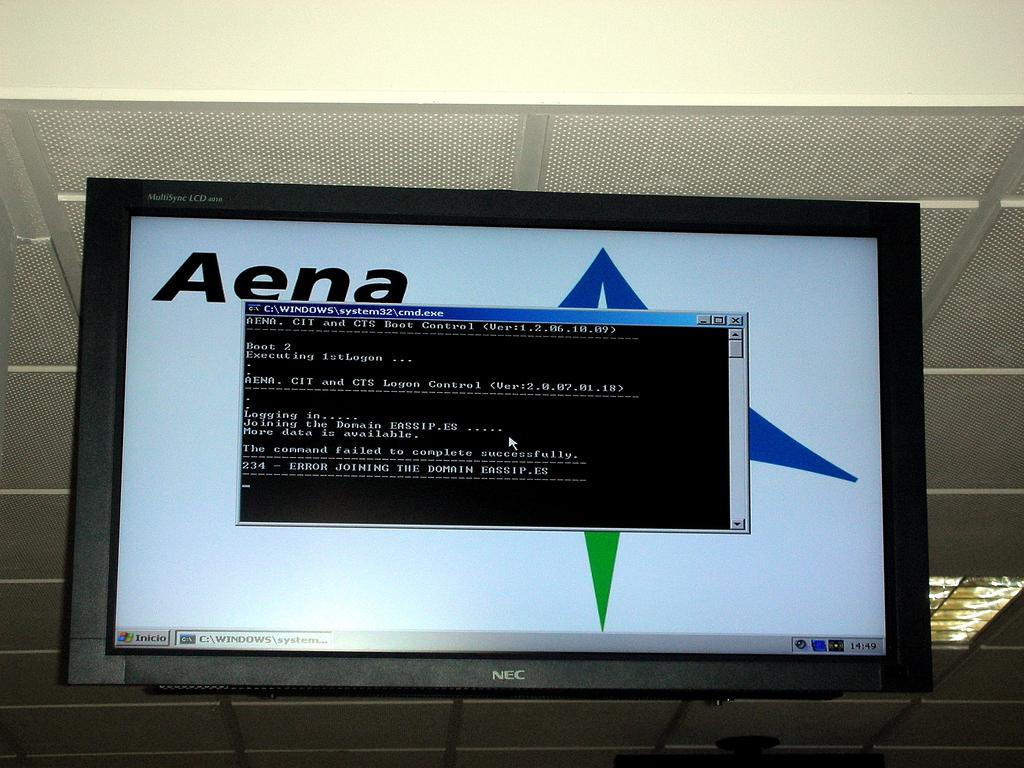<image>
Create a compact narrative representing the image presented. A Windows command prompt displays an error for joining a domain. 